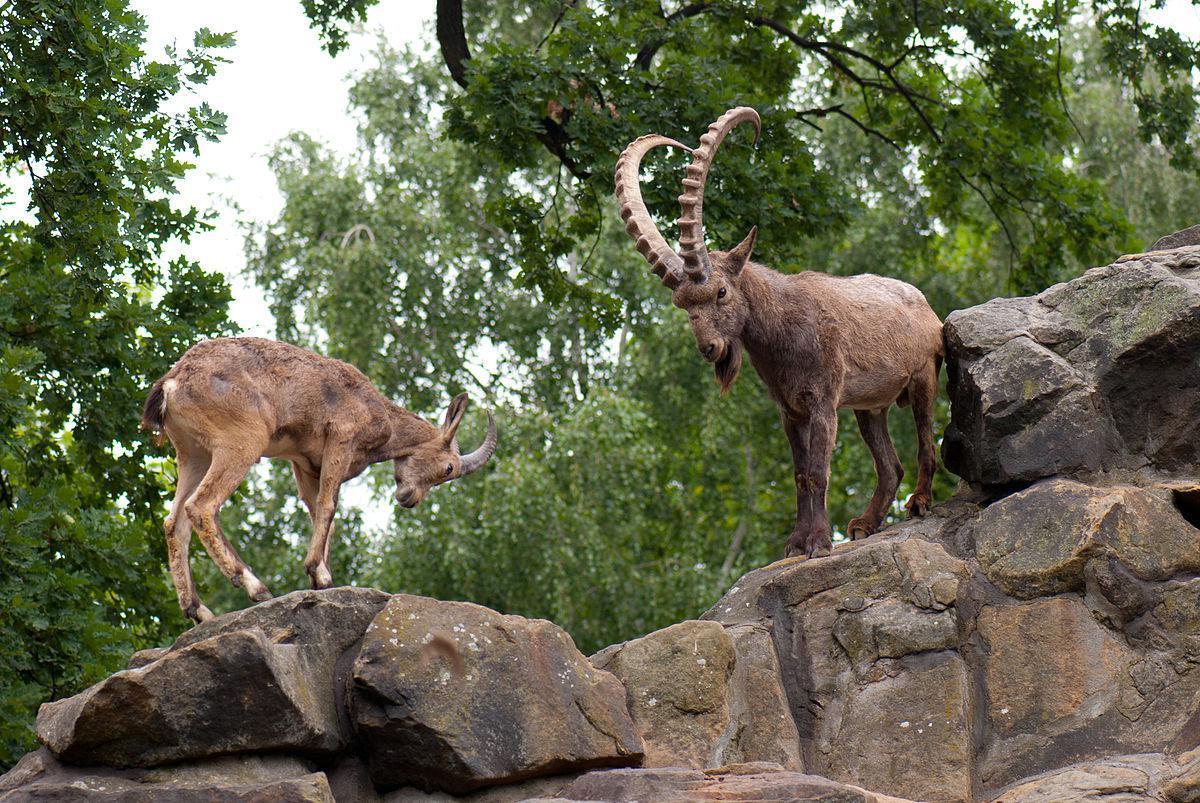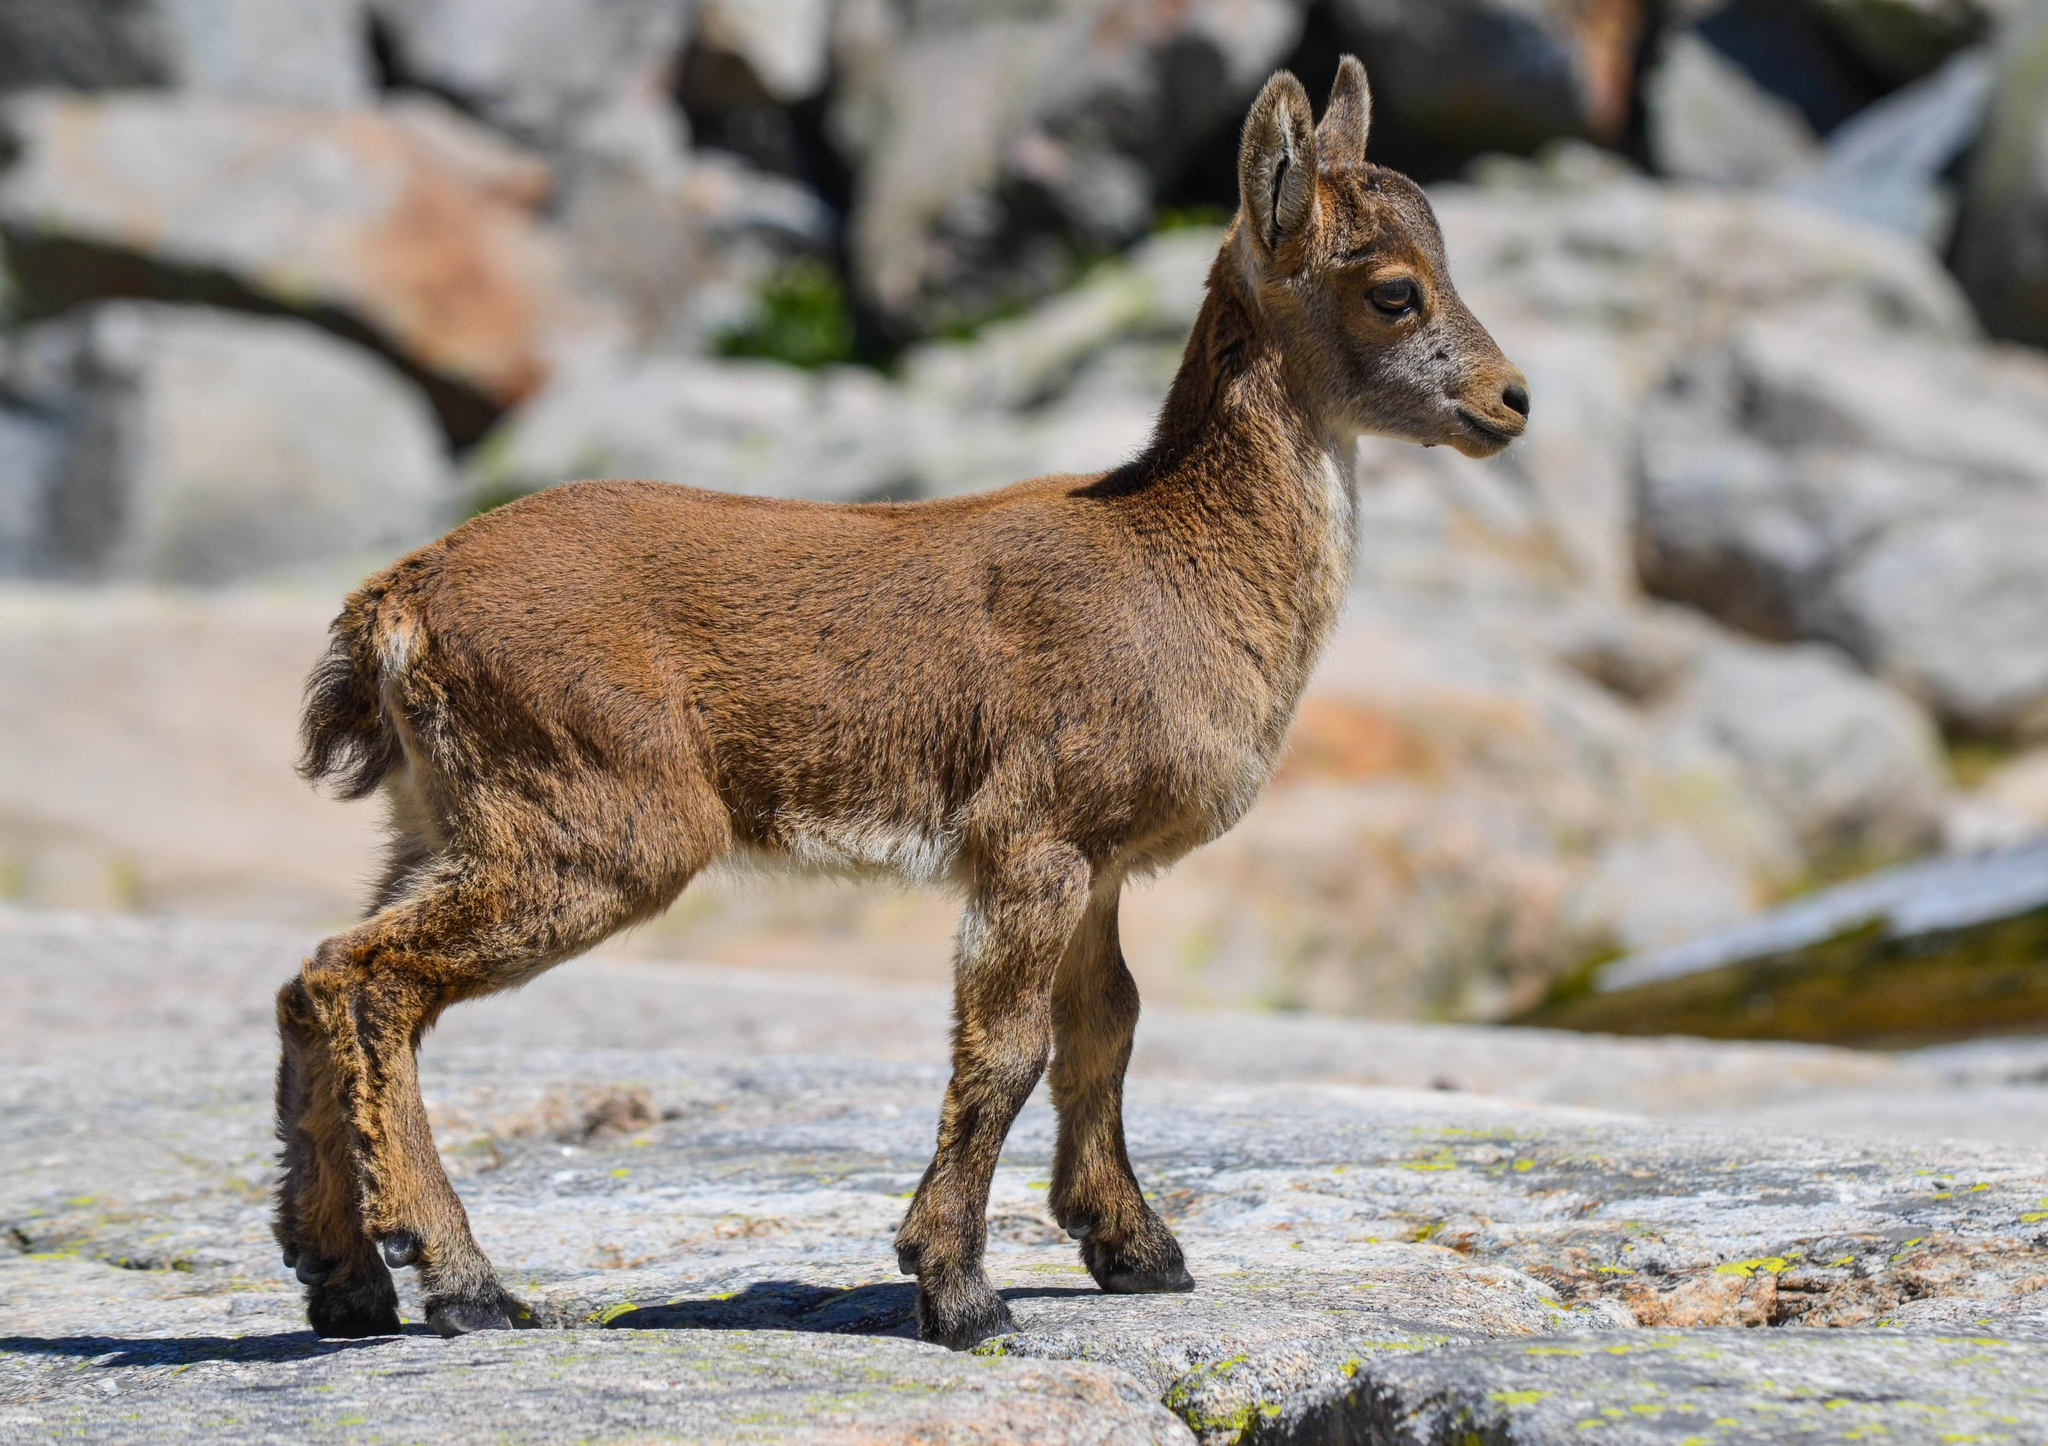The first image is the image on the left, the second image is the image on the right. Given the left and right images, does the statement "There are two animals in the image on the left." hold true? Answer yes or no. Yes. The first image is the image on the left, the second image is the image on the right. Assess this claim about the two images: "The left image contains exactly two mountain goats.". Correct or not? Answer yes or no. Yes. 